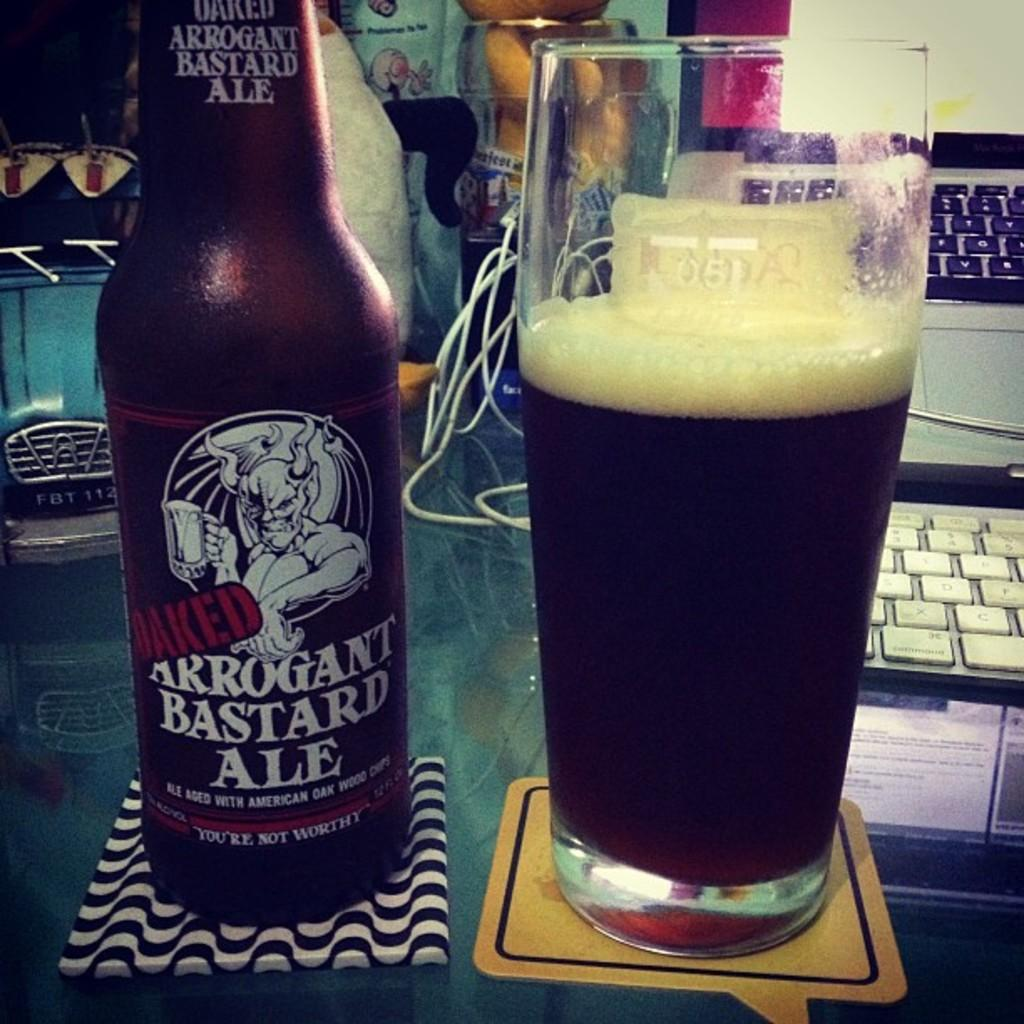<image>
Give a short and clear explanation of the subsequent image. Arrogant Bastard Ale aged with American Oak Wood and a tall beer glass. 